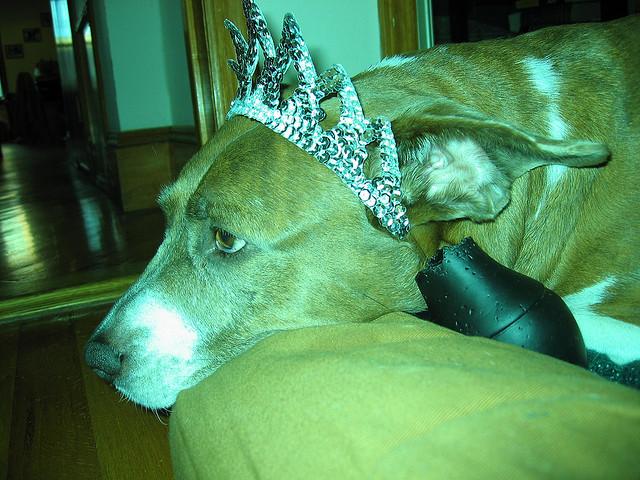What is the dog wearing on it's head?
Answer briefly. Tiara. Can you see the dog's paws?
Keep it brief. No. Why is the dog so sad?
Answer briefly. Wearing crown. 